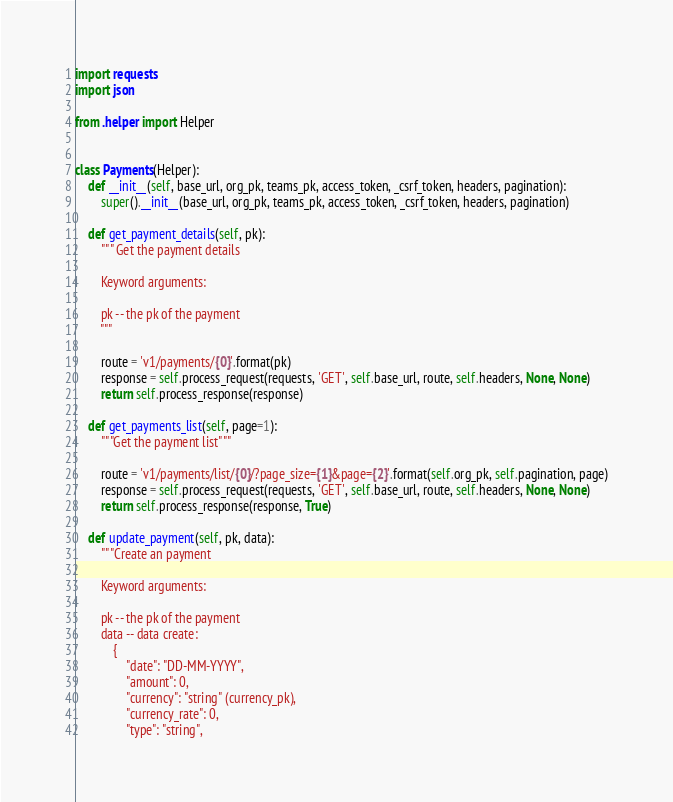<code> <loc_0><loc_0><loc_500><loc_500><_Python_>import requests
import json

from .helper import Helper


class Payments(Helper):
    def __init__(self, base_url, org_pk, teams_pk, access_token, _csrf_token, headers, pagination):
        super().__init__(base_url, org_pk, teams_pk, access_token, _csrf_token, headers, pagination)

    def get_payment_details(self, pk):
        """ Get the payment details

        Keyword arguments:

        pk -- the pk of the payment
        """

        route = 'v1/payments/{0}'.format(pk)
        response = self.process_request(requests, 'GET', self.base_url, route, self.headers, None, None)
        return self.process_response(response)

    def get_payments_list(self, page=1):
        """Get the payment list"""

        route = 'v1/payments/list/{0}/?page_size={1}&page={2}'.format(self.org_pk, self.pagination, page)
        response = self.process_request(requests, 'GET', self.base_url, route, self.headers, None, None)
        return self.process_response(response, True)

    def update_payment(self, pk, data):
        """Create an payment

        Keyword arguments:

        pk -- the pk of the payment
        data -- data create:
            {
                "date": "DD-MM-YYYY",
                "amount": 0,
                "currency": "string" (currency_pk),
                "currency_rate": 0,
                "type": "string",</code> 